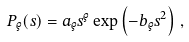<formula> <loc_0><loc_0><loc_500><loc_500>P _ { \varrho } ( s ) = a _ { \varrho } s ^ { \varrho } \exp \left ( - b _ { \varrho } s ^ { 2 } \right ) \, ,</formula> 